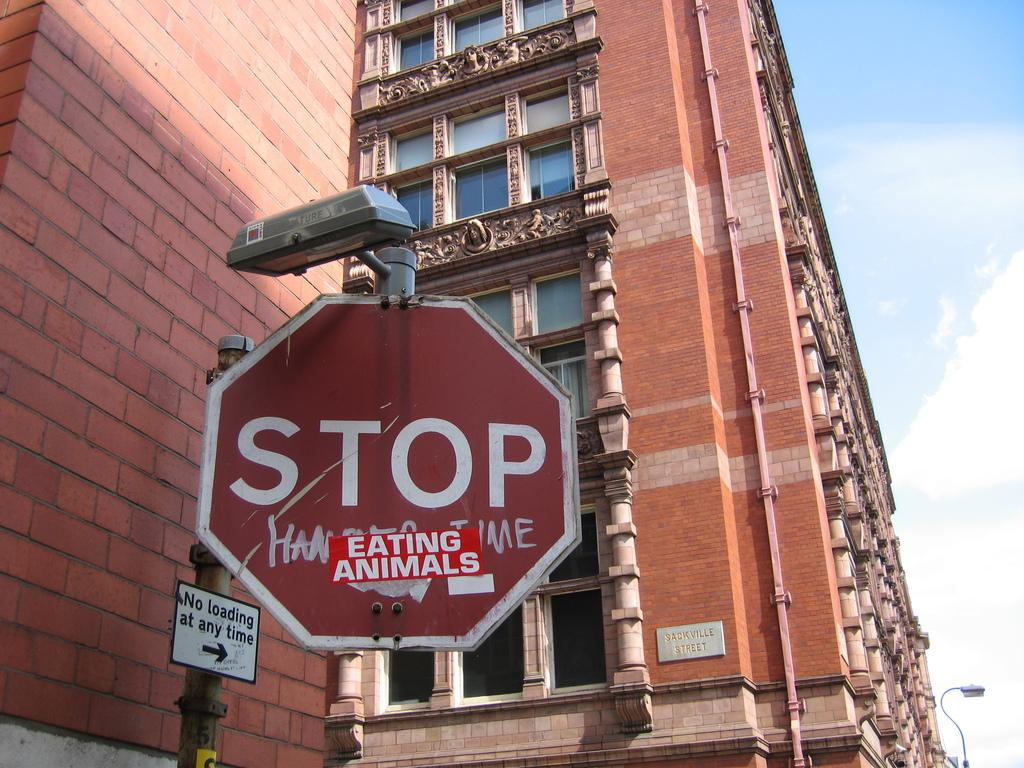<image>
Give a short and clear explanation of the subsequent image. A red and white stop sign that has a sticker that reads eating animals placed below it. 